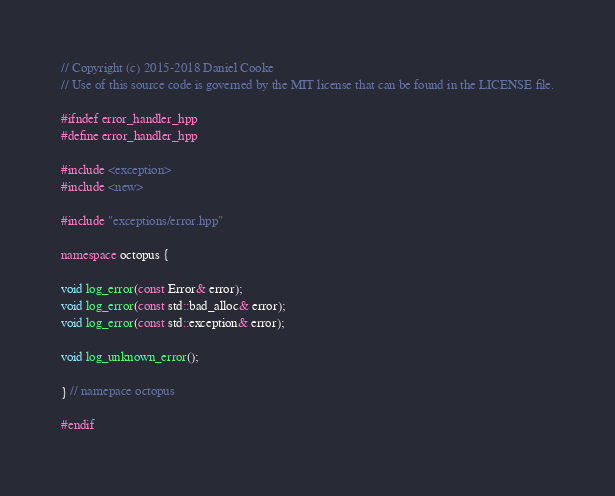<code> <loc_0><loc_0><loc_500><loc_500><_C++_>// Copyright (c) 2015-2018 Daniel Cooke
// Use of this source code is governed by the MIT license that can be found in the LICENSE file.

#ifndef error_handler_hpp
#define error_handler_hpp

#include <exception>
#include <new>

#include "exceptions/error.hpp"

namespace octopus {

void log_error(const Error& error);
void log_error(const std::bad_alloc& error);
void log_error(const std::exception& error);

void log_unknown_error();

} // namepace octopus

#endif
</code> 